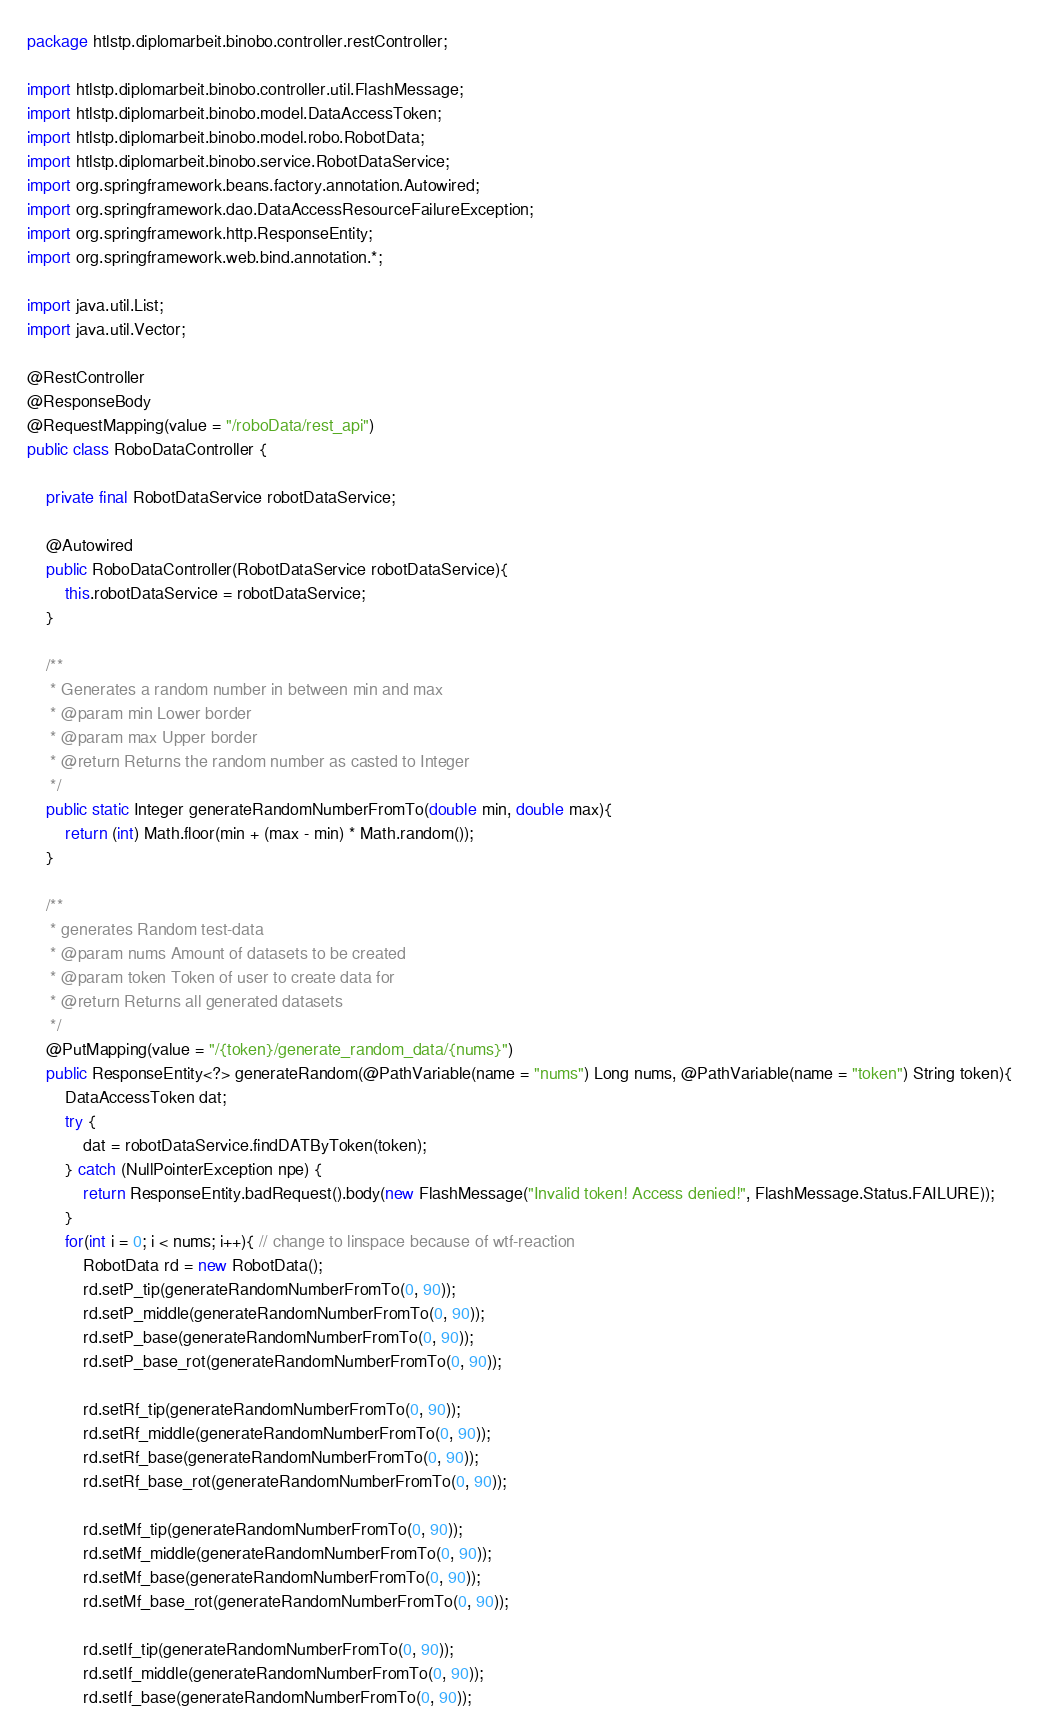<code> <loc_0><loc_0><loc_500><loc_500><_Java_>package htlstp.diplomarbeit.binobo.controller.restController;

import htlstp.diplomarbeit.binobo.controller.util.FlashMessage;
import htlstp.diplomarbeit.binobo.model.DataAccessToken;
import htlstp.diplomarbeit.binobo.model.robo.RobotData;
import htlstp.diplomarbeit.binobo.service.RobotDataService;
import org.springframework.beans.factory.annotation.Autowired;
import org.springframework.dao.DataAccessResourceFailureException;
import org.springframework.http.ResponseEntity;
import org.springframework.web.bind.annotation.*;

import java.util.List;
import java.util.Vector;

@RestController
@ResponseBody
@RequestMapping(value = "/roboData/rest_api")
public class RoboDataController {

    private final RobotDataService robotDataService;

    @Autowired
    public RoboDataController(RobotDataService robotDataService){
        this.robotDataService = robotDataService;
    }

    /**
     * Generates a random number in between min and max
     * @param min Lower border
     * @param max Upper border
     * @return Returns the random number as casted to Integer
     */
    public static Integer generateRandomNumberFromTo(double min, double max){
        return (int) Math.floor(min + (max - min) * Math.random());
    }

    /**
     * generates Random test-data
     * @param nums Amount of datasets to be created
     * @param token Token of user to create data for
     * @return Returns all generated datasets
     */
    @PutMapping(value = "/{token}/generate_random_data/{nums}")
    public ResponseEntity<?> generateRandom(@PathVariable(name = "nums") Long nums, @PathVariable(name = "token") String token){
        DataAccessToken dat;
        try {
            dat = robotDataService.findDATByToken(token);
        } catch (NullPointerException npe) {
            return ResponseEntity.badRequest().body(new FlashMessage("Invalid token! Access denied!", FlashMessage.Status.FAILURE));
        }
        for(int i = 0; i < nums; i++){ // change to linspace because of wtf-reaction
            RobotData rd = new RobotData();
            rd.setP_tip(generateRandomNumberFromTo(0, 90));
            rd.setP_middle(generateRandomNumberFromTo(0, 90));
            rd.setP_base(generateRandomNumberFromTo(0, 90));
            rd.setP_base_rot(generateRandomNumberFromTo(0, 90));

            rd.setRf_tip(generateRandomNumberFromTo(0, 90));
            rd.setRf_middle(generateRandomNumberFromTo(0, 90));
            rd.setRf_base(generateRandomNumberFromTo(0, 90));
            rd.setRf_base_rot(generateRandomNumberFromTo(0, 90));

            rd.setMf_tip(generateRandomNumberFromTo(0, 90));
            rd.setMf_middle(generateRandomNumberFromTo(0, 90));
            rd.setMf_base(generateRandomNumberFromTo(0, 90));
            rd.setMf_base_rot(generateRandomNumberFromTo(0, 90));

            rd.setIf_tip(generateRandomNumberFromTo(0, 90));
            rd.setIf_middle(generateRandomNumberFromTo(0, 90));
            rd.setIf_base(generateRandomNumberFromTo(0, 90));</code> 